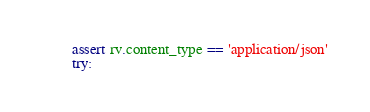<code> <loc_0><loc_0><loc_500><loc_500><_Python_>        assert rv.content_type == 'application/json'
        try:</code> 